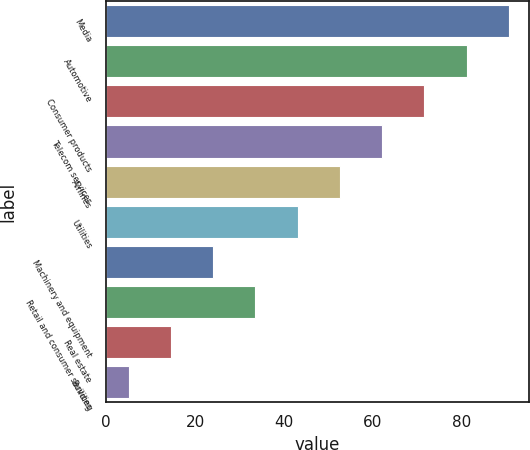<chart> <loc_0><loc_0><loc_500><loc_500><bar_chart><fcel>Media<fcel>Automotive<fcel>Consumer products<fcel>Telecom services<fcel>Airlines<fcel>Utilities<fcel>Machinery and equipment<fcel>Retail and consumer services<fcel>Real estate<fcel>Building<nl><fcel>90.51<fcel>81.02<fcel>71.53<fcel>62.04<fcel>52.55<fcel>43.06<fcel>24.08<fcel>33.57<fcel>14.59<fcel>5.1<nl></chart> 